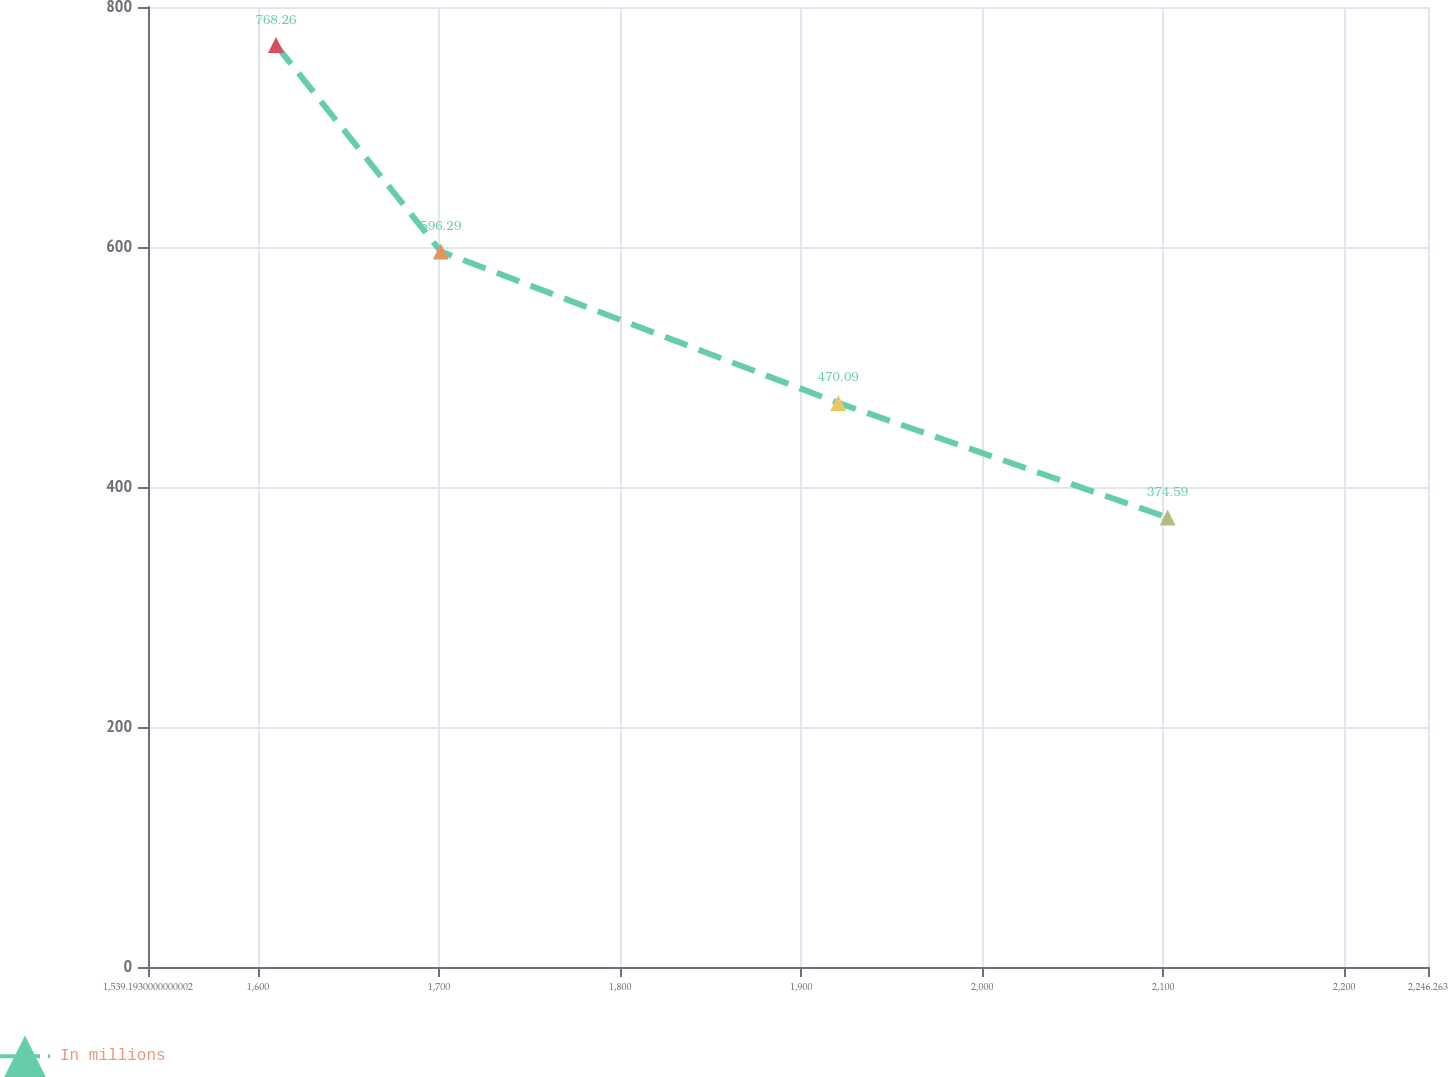<chart> <loc_0><loc_0><loc_500><loc_500><line_chart><ecel><fcel>In millions<nl><fcel>1609.9<fcel>768.26<nl><fcel>1700.94<fcel>596.29<nl><fcel>1920.48<fcel>470.09<nl><fcel>2102.42<fcel>374.59<nl><fcel>2316.97<fcel>175.27<nl></chart> 